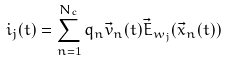<formula> <loc_0><loc_0><loc_500><loc_500>i _ { j } ( t ) = \sum _ { n = 1 } ^ { N _ { c } } q _ { n } \vec { v } _ { n } ( t ) \vec { E } _ { w _ { j } } ( \vec { x } _ { n } ( t ) )</formula> 